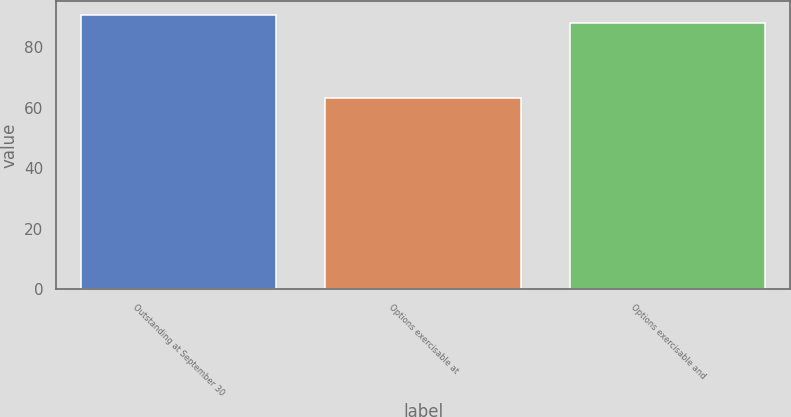Convert chart. <chart><loc_0><loc_0><loc_500><loc_500><bar_chart><fcel>Outstanding at September 30<fcel>Options exercisable at<fcel>Options exercisable and<nl><fcel>90.5<fcel>63.03<fcel>87.79<nl></chart> 